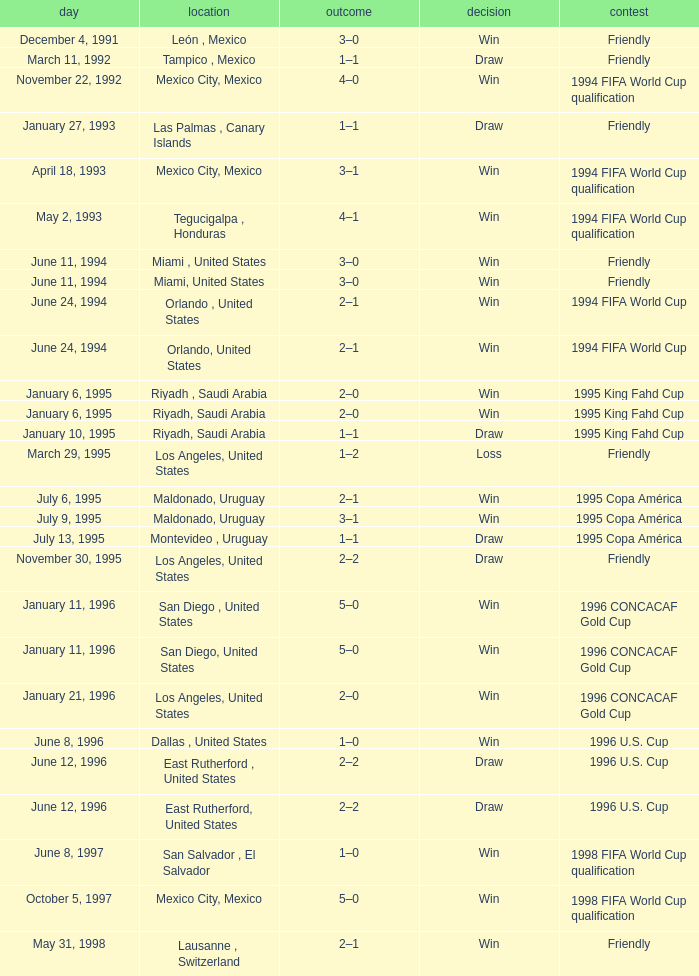What is Score, when Venue is Riyadh, Saudi Arabia, and when Result is "Win"? 2–0, 2–0. Would you be able to parse every entry in this table? {'header': ['day', 'location', 'outcome', 'decision', 'contest'], 'rows': [['December 4, 1991', 'León , Mexico', '3–0', 'Win', 'Friendly'], ['March 11, 1992', 'Tampico , Mexico', '1–1', 'Draw', 'Friendly'], ['November 22, 1992', 'Mexico City, Mexico', '4–0', 'Win', '1994 FIFA World Cup qualification'], ['January 27, 1993', 'Las Palmas , Canary Islands', '1–1', 'Draw', 'Friendly'], ['April 18, 1993', 'Mexico City, Mexico', '3–1', 'Win', '1994 FIFA World Cup qualification'], ['May 2, 1993', 'Tegucigalpa , Honduras', '4–1', 'Win', '1994 FIFA World Cup qualification'], ['June 11, 1994', 'Miami , United States', '3–0', 'Win', 'Friendly'], ['June 11, 1994', 'Miami, United States', '3–0', 'Win', 'Friendly'], ['June 24, 1994', 'Orlando , United States', '2–1', 'Win', '1994 FIFA World Cup'], ['June 24, 1994', 'Orlando, United States', '2–1', 'Win', '1994 FIFA World Cup'], ['January 6, 1995', 'Riyadh , Saudi Arabia', '2–0', 'Win', '1995 King Fahd Cup'], ['January 6, 1995', 'Riyadh, Saudi Arabia', '2–0', 'Win', '1995 King Fahd Cup'], ['January 10, 1995', 'Riyadh, Saudi Arabia', '1–1', 'Draw', '1995 King Fahd Cup'], ['March 29, 1995', 'Los Angeles, United States', '1–2', 'Loss', 'Friendly'], ['July 6, 1995', 'Maldonado, Uruguay', '2–1', 'Win', '1995 Copa América'], ['July 9, 1995', 'Maldonado, Uruguay', '3–1', 'Win', '1995 Copa América'], ['July 13, 1995', 'Montevideo , Uruguay', '1–1', 'Draw', '1995 Copa América'], ['November 30, 1995', 'Los Angeles, United States', '2–2', 'Draw', 'Friendly'], ['January 11, 1996', 'San Diego , United States', '5–0', 'Win', '1996 CONCACAF Gold Cup'], ['January 11, 1996', 'San Diego, United States', '5–0', 'Win', '1996 CONCACAF Gold Cup'], ['January 21, 1996', 'Los Angeles, United States', '2–0', 'Win', '1996 CONCACAF Gold Cup'], ['June 8, 1996', 'Dallas , United States', '1–0', 'Win', '1996 U.S. Cup'], ['June 12, 1996', 'East Rutherford , United States', '2–2', 'Draw', '1996 U.S. Cup'], ['June 12, 1996', 'East Rutherford, United States', '2–2', 'Draw', '1996 U.S. Cup'], ['June 8, 1997', 'San Salvador , El Salvador', '1–0', 'Win', '1998 FIFA World Cup qualification'], ['October 5, 1997', 'Mexico City, Mexico', '5–0', 'Win', '1998 FIFA World Cup qualification'], ['May 31, 1998', 'Lausanne , Switzerland', '2–1', 'Win', 'Friendly']]} 